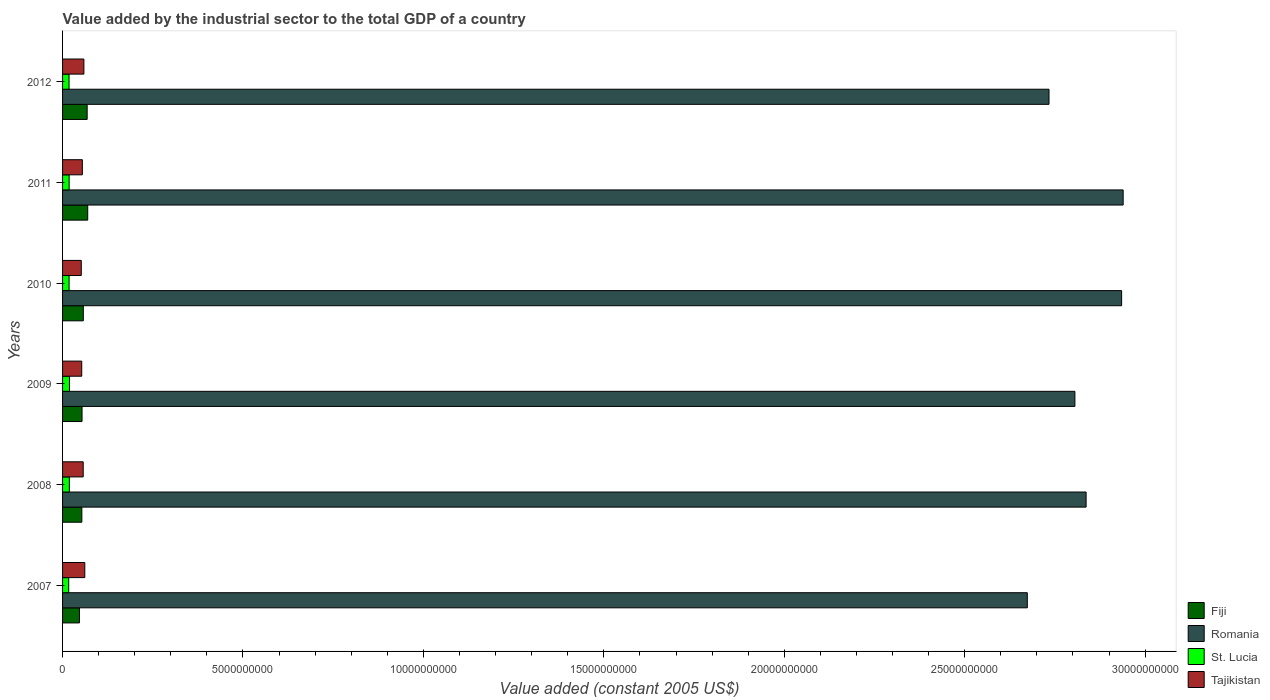How many groups of bars are there?
Your answer should be compact. 6. Are the number of bars on each tick of the Y-axis equal?
Provide a succinct answer. Yes. How many bars are there on the 3rd tick from the top?
Offer a terse response. 4. How many bars are there on the 6th tick from the bottom?
Keep it short and to the point. 4. What is the label of the 4th group of bars from the top?
Provide a succinct answer. 2009. What is the value added by the industrial sector in Fiji in 2008?
Offer a very short reply. 5.34e+08. Across all years, what is the maximum value added by the industrial sector in St. Lucia?
Your answer should be very brief. 1.91e+08. Across all years, what is the minimum value added by the industrial sector in Tajikistan?
Give a very brief answer. 5.19e+08. What is the total value added by the industrial sector in Fiji in the graph?
Keep it short and to the point. 3.49e+09. What is the difference between the value added by the industrial sector in Fiji in 2008 and that in 2009?
Offer a terse response. -5.57e+06. What is the difference between the value added by the industrial sector in Romania in 2009 and the value added by the industrial sector in Fiji in 2007?
Give a very brief answer. 2.76e+1. What is the average value added by the industrial sector in Tajikistan per year?
Keep it short and to the point. 5.63e+08. In the year 2009, what is the difference between the value added by the industrial sector in St. Lucia and value added by the industrial sector in Romania?
Your answer should be compact. -2.79e+1. What is the ratio of the value added by the industrial sector in St. Lucia in 2008 to that in 2011?
Offer a very short reply. 1.03. Is the value added by the industrial sector in Tajikistan in 2010 less than that in 2011?
Your answer should be compact. Yes. What is the difference between the highest and the second highest value added by the industrial sector in Romania?
Ensure brevity in your answer.  4.22e+07. What is the difference between the highest and the lowest value added by the industrial sector in Fiji?
Make the answer very short. 2.29e+08. What does the 1st bar from the top in 2008 represents?
Offer a very short reply. Tajikistan. What does the 2nd bar from the bottom in 2007 represents?
Offer a terse response. Romania. Are the values on the major ticks of X-axis written in scientific E-notation?
Make the answer very short. No. Does the graph contain any zero values?
Give a very brief answer. No. Does the graph contain grids?
Give a very brief answer. No. Where does the legend appear in the graph?
Your answer should be very brief. Bottom right. How many legend labels are there?
Your response must be concise. 4. What is the title of the graph?
Make the answer very short. Value added by the industrial sector to the total GDP of a country. What is the label or title of the X-axis?
Provide a short and direct response. Value added (constant 2005 US$). What is the label or title of the Y-axis?
Offer a terse response. Years. What is the Value added (constant 2005 US$) in Fiji in 2007?
Offer a terse response. 4.68e+08. What is the Value added (constant 2005 US$) in Romania in 2007?
Your answer should be compact. 2.67e+1. What is the Value added (constant 2005 US$) in St. Lucia in 2007?
Give a very brief answer. 1.70e+08. What is the Value added (constant 2005 US$) in Tajikistan in 2007?
Offer a terse response. 6.16e+08. What is the Value added (constant 2005 US$) of Fiji in 2008?
Provide a succinct answer. 5.34e+08. What is the Value added (constant 2005 US$) in Romania in 2008?
Your answer should be very brief. 2.84e+1. What is the Value added (constant 2005 US$) of St. Lucia in 2008?
Provide a short and direct response. 1.88e+08. What is the Value added (constant 2005 US$) in Tajikistan in 2008?
Offer a terse response. 5.72e+08. What is the Value added (constant 2005 US$) in Fiji in 2009?
Provide a succinct answer. 5.40e+08. What is the Value added (constant 2005 US$) in Romania in 2009?
Give a very brief answer. 2.81e+1. What is the Value added (constant 2005 US$) of St. Lucia in 2009?
Make the answer very short. 1.91e+08. What is the Value added (constant 2005 US$) of Tajikistan in 2009?
Offer a terse response. 5.31e+08. What is the Value added (constant 2005 US$) in Fiji in 2010?
Your answer should be very brief. 5.75e+08. What is the Value added (constant 2005 US$) in Romania in 2010?
Offer a very short reply. 2.93e+1. What is the Value added (constant 2005 US$) in St. Lucia in 2010?
Provide a short and direct response. 1.81e+08. What is the Value added (constant 2005 US$) in Tajikistan in 2010?
Your answer should be compact. 5.19e+08. What is the Value added (constant 2005 US$) in Fiji in 2011?
Make the answer very short. 6.97e+08. What is the Value added (constant 2005 US$) of Romania in 2011?
Your answer should be compact. 2.94e+1. What is the Value added (constant 2005 US$) in St. Lucia in 2011?
Your answer should be very brief. 1.82e+08. What is the Value added (constant 2005 US$) in Tajikistan in 2011?
Provide a short and direct response. 5.49e+08. What is the Value added (constant 2005 US$) in Fiji in 2012?
Make the answer very short. 6.81e+08. What is the Value added (constant 2005 US$) in Romania in 2012?
Keep it short and to the point. 2.73e+1. What is the Value added (constant 2005 US$) in St. Lucia in 2012?
Give a very brief answer. 1.80e+08. What is the Value added (constant 2005 US$) of Tajikistan in 2012?
Keep it short and to the point. 5.91e+08. Across all years, what is the maximum Value added (constant 2005 US$) in Fiji?
Ensure brevity in your answer.  6.97e+08. Across all years, what is the maximum Value added (constant 2005 US$) of Romania?
Ensure brevity in your answer.  2.94e+1. Across all years, what is the maximum Value added (constant 2005 US$) of St. Lucia?
Your answer should be very brief. 1.91e+08. Across all years, what is the maximum Value added (constant 2005 US$) of Tajikistan?
Offer a terse response. 6.16e+08. Across all years, what is the minimum Value added (constant 2005 US$) in Fiji?
Give a very brief answer. 4.68e+08. Across all years, what is the minimum Value added (constant 2005 US$) in Romania?
Offer a very short reply. 2.67e+1. Across all years, what is the minimum Value added (constant 2005 US$) in St. Lucia?
Your answer should be compact. 1.70e+08. Across all years, what is the minimum Value added (constant 2005 US$) of Tajikistan?
Your answer should be very brief. 5.19e+08. What is the total Value added (constant 2005 US$) in Fiji in the graph?
Ensure brevity in your answer.  3.49e+09. What is the total Value added (constant 2005 US$) in Romania in the graph?
Keep it short and to the point. 1.69e+11. What is the total Value added (constant 2005 US$) of St. Lucia in the graph?
Your answer should be very brief. 1.09e+09. What is the total Value added (constant 2005 US$) of Tajikistan in the graph?
Your response must be concise. 3.38e+09. What is the difference between the Value added (constant 2005 US$) of Fiji in 2007 and that in 2008?
Ensure brevity in your answer.  -6.59e+07. What is the difference between the Value added (constant 2005 US$) in Romania in 2007 and that in 2008?
Provide a short and direct response. -1.63e+09. What is the difference between the Value added (constant 2005 US$) in St. Lucia in 2007 and that in 2008?
Provide a succinct answer. -1.75e+07. What is the difference between the Value added (constant 2005 US$) in Tajikistan in 2007 and that in 2008?
Provide a succinct answer. 4.39e+07. What is the difference between the Value added (constant 2005 US$) in Fiji in 2007 and that in 2009?
Provide a succinct answer. -7.15e+07. What is the difference between the Value added (constant 2005 US$) of Romania in 2007 and that in 2009?
Your response must be concise. -1.32e+09. What is the difference between the Value added (constant 2005 US$) of St. Lucia in 2007 and that in 2009?
Provide a succinct answer. -2.11e+07. What is the difference between the Value added (constant 2005 US$) in Tajikistan in 2007 and that in 2009?
Your answer should be very brief. 8.45e+07. What is the difference between the Value added (constant 2005 US$) in Fiji in 2007 and that in 2010?
Offer a terse response. -1.07e+08. What is the difference between the Value added (constant 2005 US$) in Romania in 2007 and that in 2010?
Offer a terse response. -2.61e+09. What is the difference between the Value added (constant 2005 US$) of St. Lucia in 2007 and that in 2010?
Your answer should be compact. -1.04e+07. What is the difference between the Value added (constant 2005 US$) in Tajikistan in 2007 and that in 2010?
Make the answer very short. 9.73e+07. What is the difference between the Value added (constant 2005 US$) of Fiji in 2007 and that in 2011?
Give a very brief answer. -2.29e+08. What is the difference between the Value added (constant 2005 US$) of Romania in 2007 and that in 2011?
Offer a very short reply. -2.66e+09. What is the difference between the Value added (constant 2005 US$) of St. Lucia in 2007 and that in 2011?
Your response must be concise. -1.18e+07. What is the difference between the Value added (constant 2005 US$) in Tajikistan in 2007 and that in 2011?
Your response must be concise. 6.74e+07. What is the difference between the Value added (constant 2005 US$) of Fiji in 2007 and that in 2012?
Ensure brevity in your answer.  -2.13e+08. What is the difference between the Value added (constant 2005 US$) of Romania in 2007 and that in 2012?
Keep it short and to the point. -6.01e+08. What is the difference between the Value added (constant 2005 US$) of St. Lucia in 2007 and that in 2012?
Ensure brevity in your answer.  -9.38e+06. What is the difference between the Value added (constant 2005 US$) in Tajikistan in 2007 and that in 2012?
Your answer should be compact. 2.52e+07. What is the difference between the Value added (constant 2005 US$) in Fiji in 2008 and that in 2009?
Your answer should be compact. -5.57e+06. What is the difference between the Value added (constant 2005 US$) in Romania in 2008 and that in 2009?
Offer a terse response. 3.11e+08. What is the difference between the Value added (constant 2005 US$) of St. Lucia in 2008 and that in 2009?
Your answer should be compact. -3.62e+06. What is the difference between the Value added (constant 2005 US$) of Tajikistan in 2008 and that in 2009?
Make the answer very short. 4.07e+07. What is the difference between the Value added (constant 2005 US$) in Fiji in 2008 and that in 2010?
Your response must be concise. -4.08e+07. What is the difference between the Value added (constant 2005 US$) of Romania in 2008 and that in 2010?
Make the answer very short. -9.84e+08. What is the difference between the Value added (constant 2005 US$) in St. Lucia in 2008 and that in 2010?
Provide a succinct answer. 7.14e+06. What is the difference between the Value added (constant 2005 US$) in Tajikistan in 2008 and that in 2010?
Your answer should be very brief. 5.35e+07. What is the difference between the Value added (constant 2005 US$) in Fiji in 2008 and that in 2011?
Make the answer very short. -1.63e+08. What is the difference between the Value added (constant 2005 US$) in Romania in 2008 and that in 2011?
Give a very brief answer. -1.03e+09. What is the difference between the Value added (constant 2005 US$) in St. Lucia in 2008 and that in 2011?
Ensure brevity in your answer.  5.71e+06. What is the difference between the Value added (constant 2005 US$) in Tajikistan in 2008 and that in 2011?
Offer a very short reply. 2.35e+07. What is the difference between the Value added (constant 2005 US$) of Fiji in 2008 and that in 2012?
Your response must be concise. -1.47e+08. What is the difference between the Value added (constant 2005 US$) in Romania in 2008 and that in 2012?
Provide a succinct answer. 1.03e+09. What is the difference between the Value added (constant 2005 US$) in St. Lucia in 2008 and that in 2012?
Ensure brevity in your answer.  8.12e+06. What is the difference between the Value added (constant 2005 US$) of Tajikistan in 2008 and that in 2012?
Your response must be concise. -1.87e+07. What is the difference between the Value added (constant 2005 US$) in Fiji in 2009 and that in 2010?
Your response must be concise. -3.53e+07. What is the difference between the Value added (constant 2005 US$) in Romania in 2009 and that in 2010?
Your response must be concise. -1.29e+09. What is the difference between the Value added (constant 2005 US$) in St. Lucia in 2009 and that in 2010?
Ensure brevity in your answer.  1.08e+07. What is the difference between the Value added (constant 2005 US$) in Tajikistan in 2009 and that in 2010?
Provide a short and direct response. 1.28e+07. What is the difference between the Value added (constant 2005 US$) of Fiji in 2009 and that in 2011?
Your answer should be very brief. -1.57e+08. What is the difference between the Value added (constant 2005 US$) of Romania in 2009 and that in 2011?
Provide a succinct answer. -1.34e+09. What is the difference between the Value added (constant 2005 US$) of St. Lucia in 2009 and that in 2011?
Provide a short and direct response. 9.33e+06. What is the difference between the Value added (constant 2005 US$) of Tajikistan in 2009 and that in 2011?
Offer a very short reply. -1.72e+07. What is the difference between the Value added (constant 2005 US$) in Fiji in 2009 and that in 2012?
Offer a very short reply. -1.42e+08. What is the difference between the Value added (constant 2005 US$) of Romania in 2009 and that in 2012?
Give a very brief answer. 7.18e+08. What is the difference between the Value added (constant 2005 US$) in St. Lucia in 2009 and that in 2012?
Offer a terse response. 1.17e+07. What is the difference between the Value added (constant 2005 US$) of Tajikistan in 2009 and that in 2012?
Provide a short and direct response. -5.94e+07. What is the difference between the Value added (constant 2005 US$) of Fiji in 2010 and that in 2011?
Your answer should be compact. -1.22e+08. What is the difference between the Value added (constant 2005 US$) of Romania in 2010 and that in 2011?
Keep it short and to the point. -4.22e+07. What is the difference between the Value added (constant 2005 US$) of St. Lucia in 2010 and that in 2011?
Ensure brevity in your answer.  -1.43e+06. What is the difference between the Value added (constant 2005 US$) in Tajikistan in 2010 and that in 2011?
Offer a terse response. -3.00e+07. What is the difference between the Value added (constant 2005 US$) of Fiji in 2010 and that in 2012?
Offer a very short reply. -1.06e+08. What is the difference between the Value added (constant 2005 US$) of Romania in 2010 and that in 2012?
Keep it short and to the point. 2.01e+09. What is the difference between the Value added (constant 2005 US$) in St. Lucia in 2010 and that in 2012?
Provide a succinct answer. 9.80e+05. What is the difference between the Value added (constant 2005 US$) of Tajikistan in 2010 and that in 2012?
Offer a terse response. -7.22e+07. What is the difference between the Value added (constant 2005 US$) in Fiji in 2011 and that in 2012?
Ensure brevity in your answer.  1.57e+07. What is the difference between the Value added (constant 2005 US$) of Romania in 2011 and that in 2012?
Your answer should be very brief. 2.05e+09. What is the difference between the Value added (constant 2005 US$) in St. Lucia in 2011 and that in 2012?
Keep it short and to the point. 2.41e+06. What is the difference between the Value added (constant 2005 US$) in Tajikistan in 2011 and that in 2012?
Make the answer very short. -4.22e+07. What is the difference between the Value added (constant 2005 US$) of Fiji in 2007 and the Value added (constant 2005 US$) of Romania in 2008?
Offer a terse response. -2.79e+1. What is the difference between the Value added (constant 2005 US$) of Fiji in 2007 and the Value added (constant 2005 US$) of St. Lucia in 2008?
Give a very brief answer. 2.80e+08. What is the difference between the Value added (constant 2005 US$) of Fiji in 2007 and the Value added (constant 2005 US$) of Tajikistan in 2008?
Your response must be concise. -1.04e+08. What is the difference between the Value added (constant 2005 US$) in Romania in 2007 and the Value added (constant 2005 US$) in St. Lucia in 2008?
Your response must be concise. 2.65e+1. What is the difference between the Value added (constant 2005 US$) in Romania in 2007 and the Value added (constant 2005 US$) in Tajikistan in 2008?
Your answer should be very brief. 2.62e+1. What is the difference between the Value added (constant 2005 US$) in St. Lucia in 2007 and the Value added (constant 2005 US$) in Tajikistan in 2008?
Your answer should be very brief. -4.02e+08. What is the difference between the Value added (constant 2005 US$) of Fiji in 2007 and the Value added (constant 2005 US$) of Romania in 2009?
Ensure brevity in your answer.  -2.76e+1. What is the difference between the Value added (constant 2005 US$) of Fiji in 2007 and the Value added (constant 2005 US$) of St. Lucia in 2009?
Provide a succinct answer. 2.77e+08. What is the difference between the Value added (constant 2005 US$) in Fiji in 2007 and the Value added (constant 2005 US$) in Tajikistan in 2009?
Provide a short and direct response. -6.32e+07. What is the difference between the Value added (constant 2005 US$) in Romania in 2007 and the Value added (constant 2005 US$) in St. Lucia in 2009?
Keep it short and to the point. 2.65e+1. What is the difference between the Value added (constant 2005 US$) in Romania in 2007 and the Value added (constant 2005 US$) in Tajikistan in 2009?
Your answer should be compact. 2.62e+1. What is the difference between the Value added (constant 2005 US$) of St. Lucia in 2007 and the Value added (constant 2005 US$) of Tajikistan in 2009?
Keep it short and to the point. -3.61e+08. What is the difference between the Value added (constant 2005 US$) in Fiji in 2007 and the Value added (constant 2005 US$) in Romania in 2010?
Keep it short and to the point. -2.89e+1. What is the difference between the Value added (constant 2005 US$) of Fiji in 2007 and the Value added (constant 2005 US$) of St. Lucia in 2010?
Make the answer very short. 2.87e+08. What is the difference between the Value added (constant 2005 US$) in Fiji in 2007 and the Value added (constant 2005 US$) in Tajikistan in 2010?
Your answer should be compact. -5.04e+07. What is the difference between the Value added (constant 2005 US$) of Romania in 2007 and the Value added (constant 2005 US$) of St. Lucia in 2010?
Provide a short and direct response. 2.66e+1. What is the difference between the Value added (constant 2005 US$) of Romania in 2007 and the Value added (constant 2005 US$) of Tajikistan in 2010?
Your response must be concise. 2.62e+1. What is the difference between the Value added (constant 2005 US$) in St. Lucia in 2007 and the Value added (constant 2005 US$) in Tajikistan in 2010?
Your response must be concise. -3.48e+08. What is the difference between the Value added (constant 2005 US$) of Fiji in 2007 and the Value added (constant 2005 US$) of Romania in 2011?
Your answer should be very brief. -2.89e+1. What is the difference between the Value added (constant 2005 US$) in Fiji in 2007 and the Value added (constant 2005 US$) in St. Lucia in 2011?
Offer a terse response. 2.86e+08. What is the difference between the Value added (constant 2005 US$) in Fiji in 2007 and the Value added (constant 2005 US$) in Tajikistan in 2011?
Make the answer very short. -8.04e+07. What is the difference between the Value added (constant 2005 US$) in Romania in 2007 and the Value added (constant 2005 US$) in St. Lucia in 2011?
Offer a terse response. 2.66e+1. What is the difference between the Value added (constant 2005 US$) of Romania in 2007 and the Value added (constant 2005 US$) of Tajikistan in 2011?
Provide a succinct answer. 2.62e+1. What is the difference between the Value added (constant 2005 US$) in St. Lucia in 2007 and the Value added (constant 2005 US$) in Tajikistan in 2011?
Give a very brief answer. -3.78e+08. What is the difference between the Value added (constant 2005 US$) in Fiji in 2007 and the Value added (constant 2005 US$) in Romania in 2012?
Give a very brief answer. -2.69e+1. What is the difference between the Value added (constant 2005 US$) in Fiji in 2007 and the Value added (constant 2005 US$) in St. Lucia in 2012?
Give a very brief answer. 2.88e+08. What is the difference between the Value added (constant 2005 US$) in Fiji in 2007 and the Value added (constant 2005 US$) in Tajikistan in 2012?
Your answer should be very brief. -1.23e+08. What is the difference between the Value added (constant 2005 US$) in Romania in 2007 and the Value added (constant 2005 US$) in St. Lucia in 2012?
Offer a very short reply. 2.66e+1. What is the difference between the Value added (constant 2005 US$) in Romania in 2007 and the Value added (constant 2005 US$) in Tajikistan in 2012?
Offer a very short reply. 2.61e+1. What is the difference between the Value added (constant 2005 US$) in St. Lucia in 2007 and the Value added (constant 2005 US$) in Tajikistan in 2012?
Give a very brief answer. -4.20e+08. What is the difference between the Value added (constant 2005 US$) in Fiji in 2008 and the Value added (constant 2005 US$) in Romania in 2009?
Make the answer very short. -2.75e+1. What is the difference between the Value added (constant 2005 US$) in Fiji in 2008 and the Value added (constant 2005 US$) in St. Lucia in 2009?
Keep it short and to the point. 3.43e+08. What is the difference between the Value added (constant 2005 US$) in Fiji in 2008 and the Value added (constant 2005 US$) in Tajikistan in 2009?
Provide a short and direct response. 2.71e+06. What is the difference between the Value added (constant 2005 US$) in Romania in 2008 and the Value added (constant 2005 US$) in St. Lucia in 2009?
Ensure brevity in your answer.  2.82e+1. What is the difference between the Value added (constant 2005 US$) of Romania in 2008 and the Value added (constant 2005 US$) of Tajikistan in 2009?
Your response must be concise. 2.78e+1. What is the difference between the Value added (constant 2005 US$) of St. Lucia in 2008 and the Value added (constant 2005 US$) of Tajikistan in 2009?
Provide a succinct answer. -3.44e+08. What is the difference between the Value added (constant 2005 US$) of Fiji in 2008 and the Value added (constant 2005 US$) of Romania in 2010?
Your answer should be very brief. -2.88e+1. What is the difference between the Value added (constant 2005 US$) of Fiji in 2008 and the Value added (constant 2005 US$) of St. Lucia in 2010?
Offer a very short reply. 3.53e+08. What is the difference between the Value added (constant 2005 US$) in Fiji in 2008 and the Value added (constant 2005 US$) in Tajikistan in 2010?
Provide a short and direct response. 1.55e+07. What is the difference between the Value added (constant 2005 US$) of Romania in 2008 and the Value added (constant 2005 US$) of St. Lucia in 2010?
Offer a terse response. 2.82e+1. What is the difference between the Value added (constant 2005 US$) in Romania in 2008 and the Value added (constant 2005 US$) in Tajikistan in 2010?
Give a very brief answer. 2.78e+1. What is the difference between the Value added (constant 2005 US$) of St. Lucia in 2008 and the Value added (constant 2005 US$) of Tajikistan in 2010?
Make the answer very short. -3.31e+08. What is the difference between the Value added (constant 2005 US$) of Fiji in 2008 and the Value added (constant 2005 US$) of Romania in 2011?
Offer a terse response. -2.89e+1. What is the difference between the Value added (constant 2005 US$) in Fiji in 2008 and the Value added (constant 2005 US$) in St. Lucia in 2011?
Provide a succinct answer. 3.52e+08. What is the difference between the Value added (constant 2005 US$) of Fiji in 2008 and the Value added (constant 2005 US$) of Tajikistan in 2011?
Ensure brevity in your answer.  -1.45e+07. What is the difference between the Value added (constant 2005 US$) in Romania in 2008 and the Value added (constant 2005 US$) in St. Lucia in 2011?
Give a very brief answer. 2.82e+1. What is the difference between the Value added (constant 2005 US$) in Romania in 2008 and the Value added (constant 2005 US$) in Tajikistan in 2011?
Your response must be concise. 2.78e+1. What is the difference between the Value added (constant 2005 US$) in St. Lucia in 2008 and the Value added (constant 2005 US$) in Tajikistan in 2011?
Give a very brief answer. -3.61e+08. What is the difference between the Value added (constant 2005 US$) in Fiji in 2008 and the Value added (constant 2005 US$) in Romania in 2012?
Give a very brief answer. -2.68e+1. What is the difference between the Value added (constant 2005 US$) of Fiji in 2008 and the Value added (constant 2005 US$) of St. Lucia in 2012?
Your answer should be very brief. 3.54e+08. What is the difference between the Value added (constant 2005 US$) in Fiji in 2008 and the Value added (constant 2005 US$) in Tajikistan in 2012?
Offer a terse response. -5.67e+07. What is the difference between the Value added (constant 2005 US$) of Romania in 2008 and the Value added (constant 2005 US$) of St. Lucia in 2012?
Your answer should be very brief. 2.82e+1. What is the difference between the Value added (constant 2005 US$) in Romania in 2008 and the Value added (constant 2005 US$) in Tajikistan in 2012?
Your answer should be very brief. 2.78e+1. What is the difference between the Value added (constant 2005 US$) in St. Lucia in 2008 and the Value added (constant 2005 US$) in Tajikistan in 2012?
Your answer should be very brief. -4.03e+08. What is the difference between the Value added (constant 2005 US$) in Fiji in 2009 and the Value added (constant 2005 US$) in Romania in 2010?
Give a very brief answer. -2.88e+1. What is the difference between the Value added (constant 2005 US$) of Fiji in 2009 and the Value added (constant 2005 US$) of St. Lucia in 2010?
Ensure brevity in your answer.  3.59e+08. What is the difference between the Value added (constant 2005 US$) of Fiji in 2009 and the Value added (constant 2005 US$) of Tajikistan in 2010?
Give a very brief answer. 2.11e+07. What is the difference between the Value added (constant 2005 US$) in Romania in 2009 and the Value added (constant 2005 US$) in St. Lucia in 2010?
Make the answer very short. 2.79e+1. What is the difference between the Value added (constant 2005 US$) in Romania in 2009 and the Value added (constant 2005 US$) in Tajikistan in 2010?
Make the answer very short. 2.75e+1. What is the difference between the Value added (constant 2005 US$) of St. Lucia in 2009 and the Value added (constant 2005 US$) of Tajikistan in 2010?
Your answer should be very brief. -3.27e+08. What is the difference between the Value added (constant 2005 US$) in Fiji in 2009 and the Value added (constant 2005 US$) in Romania in 2011?
Provide a short and direct response. -2.89e+1. What is the difference between the Value added (constant 2005 US$) in Fiji in 2009 and the Value added (constant 2005 US$) in St. Lucia in 2011?
Provide a short and direct response. 3.58e+08. What is the difference between the Value added (constant 2005 US$) in Fiji in 2009 and the Value added (constant 2005 US$) in Tajikistan in 2011?
Offer a very short reply. -8.89e+06. What is the difference between the Value added (constant 2005 US$) of Romania in 2009 and the Value added (constant 2005 US$) of St. Lucia in 2011?
Your answer should be compact. 2.79e+1. What is the difference between the Value added (constant 2005 US$) of Romania in 2009 and the Value added (constant 2005 US$) of Tajikistan in 2011?
Provide a succinct answer. 2.75e+1. What is the difference between the Value added (constant 2005 US$) in St. Lucia in 2009 and the Value added (constant 2005 US$) in Tajikistan in 2011?
Give a very brief answer. -3.57e+08. What is the difference between the Value added (constant 2005 US$) in Fiji in 2009 and the Value added (constant 2005 US$) in Romania in 2012?
Offer a terse response. -2.68e+1. What is the difference between the Value added (constant 2005 US$) in Fiji in 2009 and the Value added (constant 2005 US$) in St. Lucia in 2012?
Give a very brief answer. 3.60e+08. What is the difference between the Value added (constant 2005 US$) in Fiji in 2009 and the Value added (constant 2005 US$) in Tajikistan in 2012?
Offer a terse response. -5.11e+07. What is the difference between the Value added (constant 2005 US$) in Romania in 2009 and the Value added (constant 2005 US$) in St. Lucia in 2012?
Offer a very short reply. 2.79e+1. What is the difference between the Value added (constant 2005 US$) of Romania in 2009 and the Value added (constant 2005 US$) of Tajikistan in 2012?
Ensure brevity in your answer.  2.75e+1. What is the difference between the Value added (constant 2005 US$) in St. Lucia in 2009 and the Value added (constant 2005 US$) in Tajikistan in 2012?
Make the answer very short. -3.99e+08. What is the difference between the Value added (constant 2005 US$) in Fiji in 2010 and the Value added (constant 2005 US$) in Romania in 2011?
Provide a succinct answer. -2.88e+1. What is the difference between the Value added (constant 2005 US$) in Fiji in 2010 and the Value added (constant 2005 US$) in St. Lucia in 2011?
Offer a very short reply. 3.93e+08. What is the difference between the Value added (constant 2005 US$) in Fiji in 2010 and the Value added (constant 2005 US$) in Tajikistan in 2011?
Offer a terse response. 2.64e+07. What is the difference between the Value added (constant 2005 US$) of Romania in 2010 and the Value added (constant 2005 US$) of St. Lucia in 2011?
Your answer should be compact. 2.92e+1. What is the difference between the Value added (constant 2005 US$) in Romania in 2010 and the Value added (constant 2005 US$) in Tajikistan in 2011?
Give a very brief answer. 2.88e+1. What is the difference between the Value added (constant 2005 US$) in St. Lucia in 2010 and the Value added (constant 2005 US$) in Tajikistan in 2011?
Provide a succinct answer. -3.68e+08. What is the difference between the Value added (constant 2005 US$) of Fiji in 2010 and the Value added (constant 2005 US$) of Romania in 2012?
Provide a short and direct response. -2.68e+1. What is the difference between the Value added (constant 2005 US$) in Fiji in 2010 and the Value added (constant 2005 US$) in St. Lucia in 2012?
Give a very brief answer. 3.95e+08. What is the difference between the Value added (constant 2005 US$) in Fiji in 2010 and the Value added (constant 2005 US$) in Tajikistan in 2012?
Offer a very short reply. -1.58e+07. What is the difference between the Value added (constant 2005 US$) of Romania in 2010 and the Value added (constant 2005 US$) of St. Lucia in 2012?
Make the answer very short. 2.92e+1. What is the difference between the Value added (constant 2005 US$) of Romania in 2010 and the Value added (constant 2005 US$) of Tajikistan in 2012?
Ensure brevity in your answer.  2.88e+1. What is the difference between the Value added (constant 2005 US$) in St. Lucia in 2010 and the Value added (constant 2005 US$) in Tajikistan in 2012?
Make the answer very short. -4.10e+08. What is the difference between the Value added (constant 2005 US$) of Fiji in 2011 and the Value added (constant 2005 US$) of Romania in 2012?
Make the answer very short. -2.66e+1. What is the difference between the Value added (constant 2005 US$) in Fiji in 2011 and the Value added (constant 2005 US$) in St. Lucia in 2012?
Make the answer very short. 5.17e+08. What is the difference between the Value added (constant 2005 US$) of Fiji in 2011 and the Value added (constant 2005 US$) of Tajikistan in 2012?
Make the answer very short. 1.06e+08. What is the difference between the Value added (constant 2005 US$) of Romania in 2011 and the Value added (constant 2005 US$) of St. Lucia in 2012?
Your answer should be compact. 2.92e+1. What is the difference between the Value added (constant 2005 US$) of Romania in 2011 and the Value added (constant 2005 US$) of Tajikistan in 2012?
Provide a short and direct response. 2.88e+1. What is the difference between the Value added (constant 2005 US$) of St. Lucia in 2011 and the Value added (constant 2005 US$) of Tajikistan in 2012?
Offer a very short reply. -4.09e+08. What is the average Value added (constant 2005 US$) of Fiji per year?
Offer a terse response. 5.82e+08. What is the average Value added (constant 2005 US$) of Romania per year?
Keep it short and to the point. 2.82e+1. What is the average Value added (constant 2005 US$) of St. Lucia per year?
Your response must be concise. 1.82e+08. What is the average Value added (constant 2005 US$) of Tajikistan per year?
Ensure brevity in your answer.  5.63e+08. In the year 2007, what is the difference between the Value added (constant 2005 US$) in Fiji and Value added (constant 2005 US$) in Romania?
Provide a short and direct response. -2.63e+1. In the year 2007, what is the difference between the Value added (constant 2005 US$) in Fiji and Value added (constant 2005 US$) in St. Lucia?
Give a very brief answer. 2.98e+08. In the year 2007, what is the difference between the Value added (constant 2005 US$) in Fiji and Value added (constant 2005 US$) in Tajikistan?
Provide a short and direct response. -1.48e+08. In the year 2007, what is the difference between the Value added (constant 2005 US$) of Romania and Value added (constant 2005 US$) of St. Lucia?
Provide a short and direct response. 2.66e+1. In the year 2007, what is the difference between the Value added (constant 2005 US$) of Romania and Value added (constant 2005 US$) of Tajikistan?
Give a very brief answer. 2.61e+1. In the year 2007, what is the difference between the Value added (constant 2005 US$) of St. Lucia and Value added (constant 2005 US$) of Tajikistan?
Offer a terse response. -4.46e+08. In the year 2008, what is the difference between the Value added (constant 2005 US$) of Fiji and Value added (constant 2005 US$) of Romania?
Keep it short and to the point. -2.78e+1. In the year 2008, what is the difference between the Value added (constant 2005 US$) of Fiji and Value added (constant 2005 US$) of St. Lucia?
Your response must be concise. 3.46e+08. In the year 2008, what is the difference between the Value added (constant 2005 US$) in Fiji and Value added (constant 2005 US$) in Tajikistan?
Ensure brevity in your answer.  -3.80e+07. In the year 2008, what is the difference between the Value added (constant 2005 US$) of Romania and Value added (constant 2005 US$) of St. Lucia?
Keep it short and to the point. 2.82e+1. In the year 2008, what is the difference between the Value added (constant 2005 US$) in Romania and Value added (constant 2005 US$) in Tajikistan?
Provide a succinct answer. 2.78e+1. In the year 2008, what is the difference between the Value added (constant 2005 US$) in St. Lucia and Value added (constant 2005 US$) in Tajikistan?
Your response must be concise. -3.84e+08. In the year 2009, what is the difference between the Value added (constant 2005 US$) in Fiji and Value added (constant 2005 US$) in Romania?
Offer a terse response. -2.75e+1. In the year 2009, what is the difference between the Value added (constant 2005 US$) in Fiji and Value added (constant 2005 US$) in St. Lucia?
Give a very brief answer. 3.48e+08. In the year 2009, what is the difference between the Value added (constant 2005 US$) in Fiji and Value added (constant 2005 US$) in Tajikistan?
Your answer should be compact. 8.28e+06. In the year 2009, what is the difference between the Value added (constant 2005 US$) in Romania and Value added (constant 2005 US$) in St. Lucia?
Provide a succinct answer. 2.79e+1. In the year 2009, what is the difference between the Value added (constant 2005 US$) in Romania and Value added (constant 2005 US$) in Tajikistan?
Offer a very short reply. 2.75e+1. In the year 2009, what is the difference between the Value added (constant 2005 US$) of St. Lucia and Value added (constant 2005 US$) of Tajikistan?
Offer a very short reply. -3.40e+08. In the year 2010, what is the difference between the Value added (constant 2005 US$) of Fiji and Value added (constant 2005 US$) of Romania?
Keep it short and to the point. -2.88e+1. In the year 2010, what is the difference between the Value added (constant 2005 US$) of Fiji and Value added (constant 2005 US$) of St. Lucia?
Ensure brevity in your answer.  3.94e+08. In the year 2010, what is the difference between the Value added (constant 2005 US$) in Fiji and Value added (constant 2005 US$) in Tajikistan?
Ensure brevity in your answer.  5.63e+07. In the year 2010, what is the difference between the Value added (constant 2005 US$) of Romania and Value added (constant 2005 US$) of St. Lucia?
Provide a short and direct response. 2.92e+1. In the year 2010, what is the difference between the Value added (constant 2005 US$) of Romania and Value added (constant 2005 US$) of Tajikistan?
Keep it short and to the point. 2.88e+1. In the year 2010, what is the difference between the Value added (constant 2005 US$) in St. Lucia and Value added (constant 2005 US$) in Tajikistan?
Make the answer very short. -3.38e+08. In the year 2011, what is the difference between the Value added (constant 2005 US$) in Fiji and Value added (constant 2005 US$) in Romania?
Make the answer very short. -2.87e+1. In the year 2011, what is the difference between the Value added (constant 2005 US$) of Fiji and Value added (constant 2005 US$) of St. Lucia?
Give a very brief answer. 5.15e+08. In the year 2011, what is the difference between the Value added (constant 2005 US$) in Fiji and Value added (constant 2005 US$) in Tajikistan?
Keep it short and to the point. 1.48e+08. In the year 2011, what is the difference between the Value added (constant 2005 US$) in Romania and Value added (constant 2005 US$) in St. Lucia?
Your response must be concise. 2.92e+1. In the year 2011, what is the difference between the Value added (constant 2005 US$) of Romania and Value added (constant 2005 US$) of Tajikistan?
Your answer should be compact. 2.88e+1. In the year 2011, what is the difference between the Value added (constant 2005 US$) in St. Lucia and Value added (constant 2005 US$) in Tajikistan?
Your answer should be compact. -3.66e+08. In the year 2012, what is the difference between the Value added (constant 2005 US$) in Fiji and Value added (constant 2005 US$) in Romania?
Your answer should be compact. -2.67e+1. In the year 2012, what is the difference between the Value added (constant 2005 US$) of Fiji and Value added (constant 2005 US$) of St. Lucia?
Keep it short and to the point. 5.02e+08. In the year 2012, what is the difference between the Value added (constant 2005 US$) of Fiji and Value added (constant 2005 US$) of Tajikistan?
Make the answer very short. 9.05e+07. In the year 2012, what is the difference between the Value added (constant 2005 US$) in Romania and Value added (constant 2005 US$) in St. Lucia?
Your response must be concise. 2.72e+1. In the year 2012, what is the difference between the Value added (constant 2005 US$) of Romania and Value added (constant 2005 US$) of Tajikistan?
Your answer should be compact. 2.67e+1. In the year 2012, what is the difference between the Value added (constant 2005 US$) of St. Lucia and Value added (constant 2005 US$) of Tajikistan?
Give a very brief answer. -4.11e+08. What is the ratio of the Value added (constant 2005 US$) of Fiji in 2007 to that in 2008?
Your response must be concise. 0.88. What is the ratio of the Value added (constant 2005 US$) in Romania in 2007 to that in 2008?
Offer a very short reply. 0.94. What is the ratio of the Value added (constant 2005 US$) in St. Lucia in 2007 to that in 2008?
Your answer should be very brief. 0.91. What is the ratio of the Value added (constant 2005 US$) in Tajikistan in 2007 to that in 2008?
Give a very brief answer. 1.08. What is the ratio of the Value added (constant 2005 US$) in Fiji in 2007 to that in 2009?
Give a very brief answer. 0.87. What is the ratio of the Value added (constant 2005 US$) of Romania in 2007 to that in 2009?
Your response must be concise. 0.95. What is the ratio of the Value added (constant 2005 US$) of St. Lucia in 2007 to that in 2009?
Make the answer very short. 0.89. What is the ratio of the Value added (constant 2005 US$) of Tajikistan in 2007 to that in 2009?
Your response must be concise. 1.16. What is the ratio of the Value added (constant 2005 US$) of Fiji in 2007 to that in 2010?
Provide a succinct answer. 0.81. What is the ratio of the Value added (constant 2005 US$) in Romania in 2007 to that in 2010?
Your answer should be very brief. 0.91. What is the ratio of the Value added (constant 2005 US$) of St. Lucia in 2007 to that in 2010?
Your response must be concise. 0.94. What is the ratio of the Value added (constant 2005 US$) in Tajikistan in 2007 to that in 2010?
Offer a terse response. 1.19. What is the ratio of the Value added (constant 2005 US$) in Fiji in 2007 to that in 2011?
Your answer should be compact. 0.67. What is the ratio of the Value added (constant 2005 US$) of Romania in 2007 to that in 2011?
Provide a succinct answer. 0.91. What is the ratio of the Value added (constant 2005 US$) of St. Lucia in 2007 to that in 2011?
Keep it short and to the point. 0.94. What is the ratio of the Value added (constant 2005 US$) of Tajikistan in 2007 to that in 2011?
Your response must be concise. 1.12. What is the ratio of the Value added (constant 2005 US$) in Fiji in 2007 to that in 2012?
Your response must be concise. 0.69. What is the ratio of the Value added (constant 2005 US$) in St. Lucia in 2007 to that in 2012?
Ensure brevity in your answer.  0.95. What is the ratio of the Value added (constant 2005 US$) in Tajikistan in 2007 to that in 2012?
Provide a succinct answer. 1.04. What is the ratio of the Value added (constant 2005 US$) of Romania in 2008 to that in 2009?
Your response must be concise. 1.01. What is the ratio of the Value added (constant 2005 US$) in St. Lucia in 2008 to that in 2009?
Keep it short and to the point. 0.98. What is the ratio of the Value added (constant 2005 US$) in Tajikistan in 2008 to that in 2009?
Your answer should be very brief. 1.08. What is the ratio of the Value added (constant 2005 US$) of Fiji in 2008 to that in 2010?
Offer a terse response. 0.93. What is the ratio of the Value added (constant 2005 US$) in Romania in 2008 to that in 2010?
Your answer should be very brief. 0.97. What is the ratio of the Value added (constant 2005 US$) of St. Lucia in 2008 to that in 2010?
Your answer should be compact. 1.04. What is the ratio of the Value added (constant 2005 US$) in Tajikistan in 2008 to that in 2010?
Provide a short and direct response. 1.1. What is the ratio of the Value added (constant 2005 US$) in Fiji in 2008 to that in 2011?
Your response must be concise. 0.77. What is the ratio of the Value added (constant 2005 US$) of Romania in 2008 to that in 2011?
Offer a terse response. 0.97. What is the ratio of the Value added (constant 2005 US$) of St. Lucia in 2008 to that in 2011?
Provide a short and direct response. 1.03. What is the ratio of the Value added (constant 2005 US$) in Tajikistan in 2008 to that in 2011?
Your answer should be compact. 1.04. What is the ratio of the Value added (constant 2005 US$) of Fiji in 2008 to that in 2012?
Offer a terse response. 0.78. What is the ratio of the Value added (constant 2005 US$) in Romania in 2008 to that in 2012?
Offer a very short reply. 1.04. What is the ratio of the Value added (constant 2005 US$) of St. Lucia in 2008 to that in 2012?
Your answer should be very brief. 1.05. What is the ratio of the Value added (constant 2005 US$) of Tajikistan in 2008 to that in 2012?
Your answer should be compact. 0.97. What is the ratio of the Value added (constant 2005 US$) of Fiji in 2009 to that in 2010?
Your response must be concise. 0.94. What is the ratio of the Value added (constant 2005 US$) in Romania in 2009 to that in 2010?
Keep it short and to the point. 0.96. What is the ratio of the Value added (constant 2005 US$) in St. Lucia in 2009 to that in 2010?
Make the answer very short. 1.06. What is the ratio of the Value added (constant 2005 US$) of Tajikistan in 2009 to that in 2010?
Ensure brevity in your answer.  1.02. What is the ratio of the Value added (constant 2005 US$) of Fiji in 2009 to that in 2011?
Your response must be concise. 0.77. What is the ratio of the Value added (constant 2005 US$) in Romania in 2009 to that in 2011?
Provide a succinct answer. 0.95. What is the ratio of the Value added (constant 2005 US$) of St. Lucia in 2009 to that in 2011?
Offer a terse response. 1.05. What is the ratio of the Value added (constant 2005 US$) in Tajikistan in 2009 to that in 2011?
Your answer should be very brief. 0.97. What is the ratio of the Value added (constant 2005 US$) in Fiji in 2009 to that in 2012?
Provide a short and direct response. 0.79. What is the ratio of the Value added (constant 2005 US$) in Romania in 2009 to that in 2012?
Your answer should be very brief. 1.03. What is the ratio of the Value added (constant 2005 US$) in St. Lucia in 2009 to that in 2012?
Your response must be concise. 1.07. What is the ratio of the Value added (constant 2005 US$) in Tajikistan in 2009 to that in 2012?
Make the answer very short. 0.9. What is the ratio of the Value added (constant 2005 US$) in Fiji in 2010 to that in 2011?
Offer a very short reply. 0.82. What is the ratio of the Value added (constant 2005 US$) in Romania in 2010 to that in 2011?
Offer a terse response. 1. What is the ratio of the Value added (constant 2005 US$) in Tajikistan in 2010 to that in 2011?
Offer a very short reply. 0.95. What is the ratio of the Value added (constant 2005 US$) of Fiji in 2010 to that in 2012?
Make the answer very short. 0.84. What is the ratio of the Value added (constant 2005 US$) of Romania in 2010 to that in 2012?
Your answer should be very brief. 1.07. What is the ratio of the Value added (constant 2005 US$) of Tajikistan in 2010 to that in 2012?
Provide a short and direct response. 0.88. What is the ratio of the Value added (constant 2005 US$) of Fiji in 2011 to that in 2012?
Make the answer very short. 1.02. What is the ratio of the Value added (constant 2005 US$) of Romania in 2011 to that in 2012?
Keep it short and to the point. 1.08. What is the ratio of the Value added (constant 2005 US$) of St. Lucia in 2011 to that in 2012?
Make the answer very short. 1.01. What is the ratio of the Value added (constant 2005 US$) in Tajikistan in 2011 to that in 2012?
Provide a short and direct response. 0.93. What is the difference between the highest and the second highest Value added (constant 2005 US$) of Fiji?
Provide a short and direct response. 1.57e+07. What is the difference between the highest and the second highest Value added (constant 2005 US$) of Romania?
Give a very brief answer. 4.22e+07. What is the difference between the highest and the second highest Value added (constant 2005 US$) in St. Lucia?
Give a very brief answer. 3.62e+06. What is the difference between the highest and the second highest Value added (constant 2005 US$) of Tajikistan?
Your answer should be compact. 2.52e+07. What is the difference between the highest and the lowest Value added (constant 2005 US$) in Fiji?
Provide a succinct answer. 2.29e+08. What is the difference between the highest and the lowest Value added (constant 2005 US$) in Romania?
Give a very brief answer. 2.66e+09. What is the difference between the highest and the lowest Value added (constant 2005 US$) in St. Lucia?
Your answer should be very brief. 2.11e+07. What is the difference between the highest and the lowest Value added (constant 2005 US$) in Tajikistan?
Provide a succinct answer. 9.73e+07. 